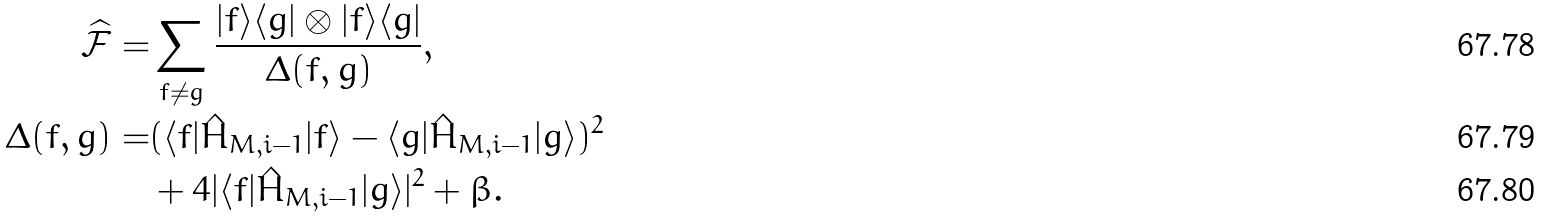<formula> <loc_0><loc_0><loc_500><loc_500>\widehat { \mathcal { F } } = & \sum _ { f \neq g } \frac { | f \rangle \langle g | \otimes | f \rangle \langle g | } { \Delta ( f , g ) } , \\ \Delta ( f , g ) = & ( \langle f | \hat { H } _ { M , i - 1 } | f \rangle - \langle g | \hat { H } _ { M , i - 1 } | g \rangle ) ^ { 2 } \\ & + 4 | \langle f | \hat { H } _ { M , i - 1 } | g \rangle | ^ { 2 } + \beta .</formula> 